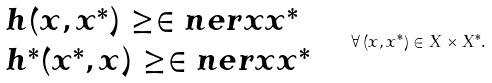<formula> <loc_0><loc_0><loc_500><loc_500>\begin{array} { l } h ( x , x ^ { * } ) \geq \in n e r { x } { x ^ { * } } \\ h ^ { * } ( x ^ { * } , x ) \geq \in n e r { x } { x ^ { * } } \end{array} \quad \forall \, ( x , x ^ { * } ) \in X \times X ^ { * } .</formula> 